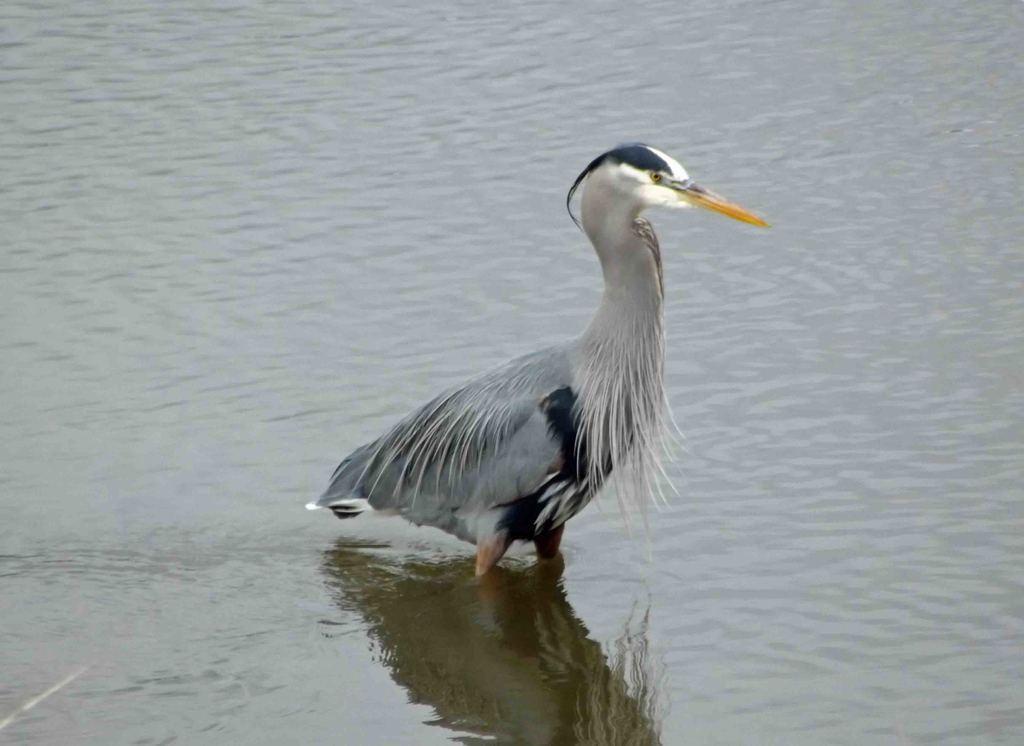Can you describe this image briefly? In the middle I can see a bird in the water. This image is taken may be in the lake during a day. 